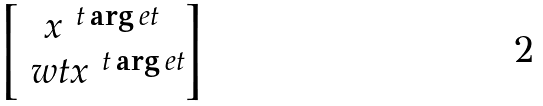Convert formula to latex. <formula><loc_0><loc_0><loc_500><loc_500>\begin{bmatrix} x ^ { \ t \arg e t } \\ \ w t x ^ { \ t \arg e t } \end{bmatrix}</formula> 